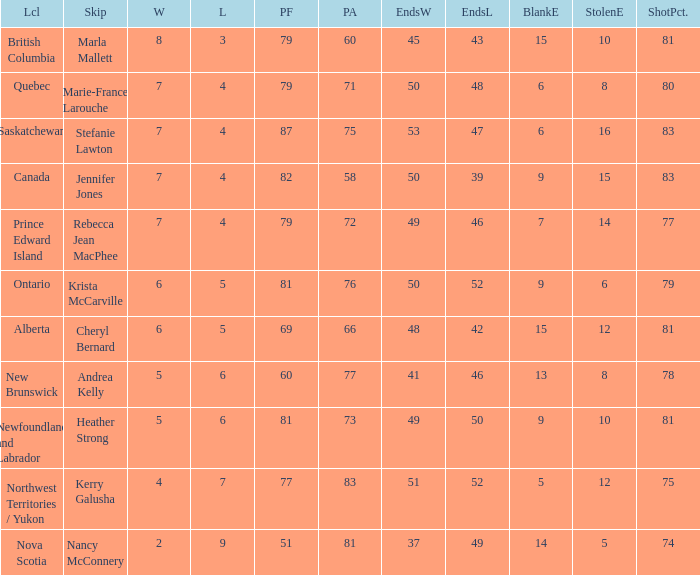What is the total of blank ends at Prince Edward Island? 7.0. 